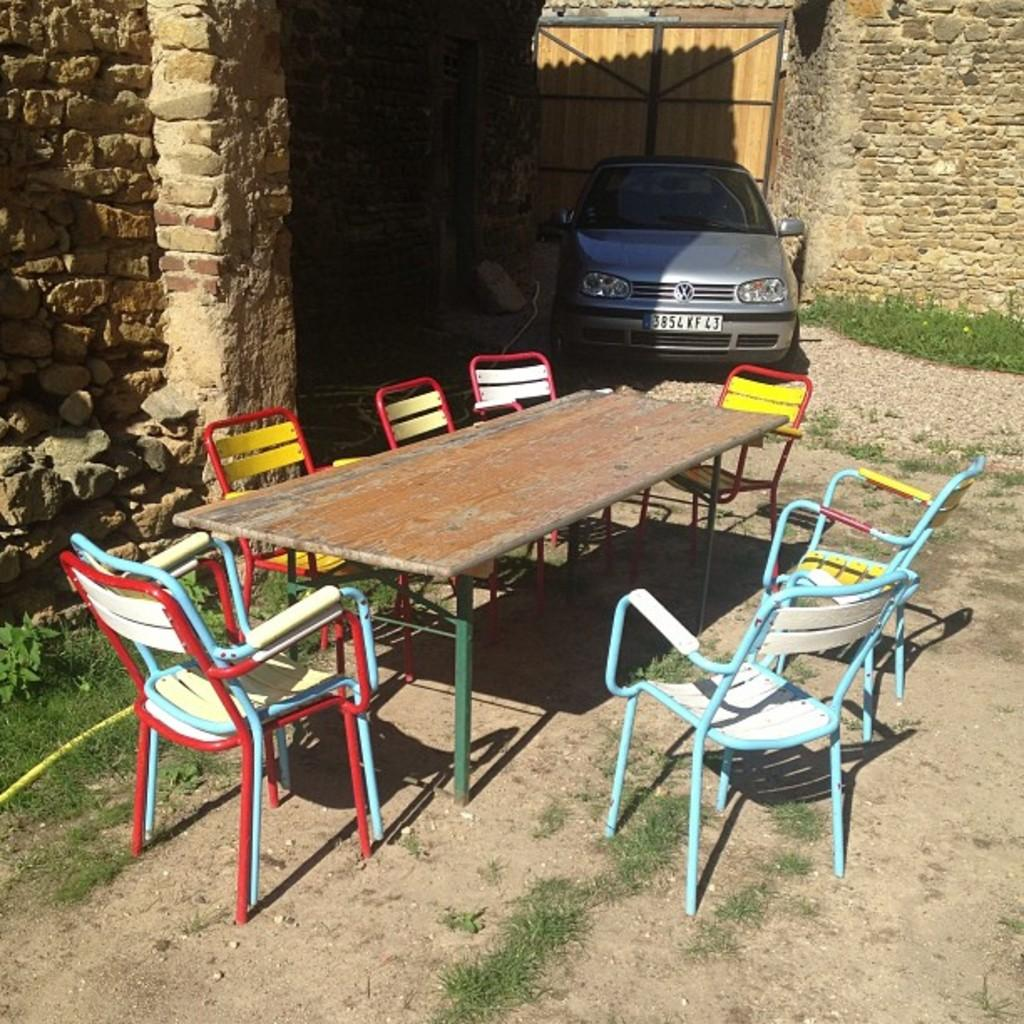What piece of furniture is in the center of the image? There is a table in the image. What accompanies the table in the image? There are chairs around the table. What can be seen in the background of the image? There is a wall, grass, and a car in the background of the image. What type of credit can be seen being processed in the image? There is no credit or process being depicted in the image; it features a table with chairs and a background with a wall, grass, and a car. 